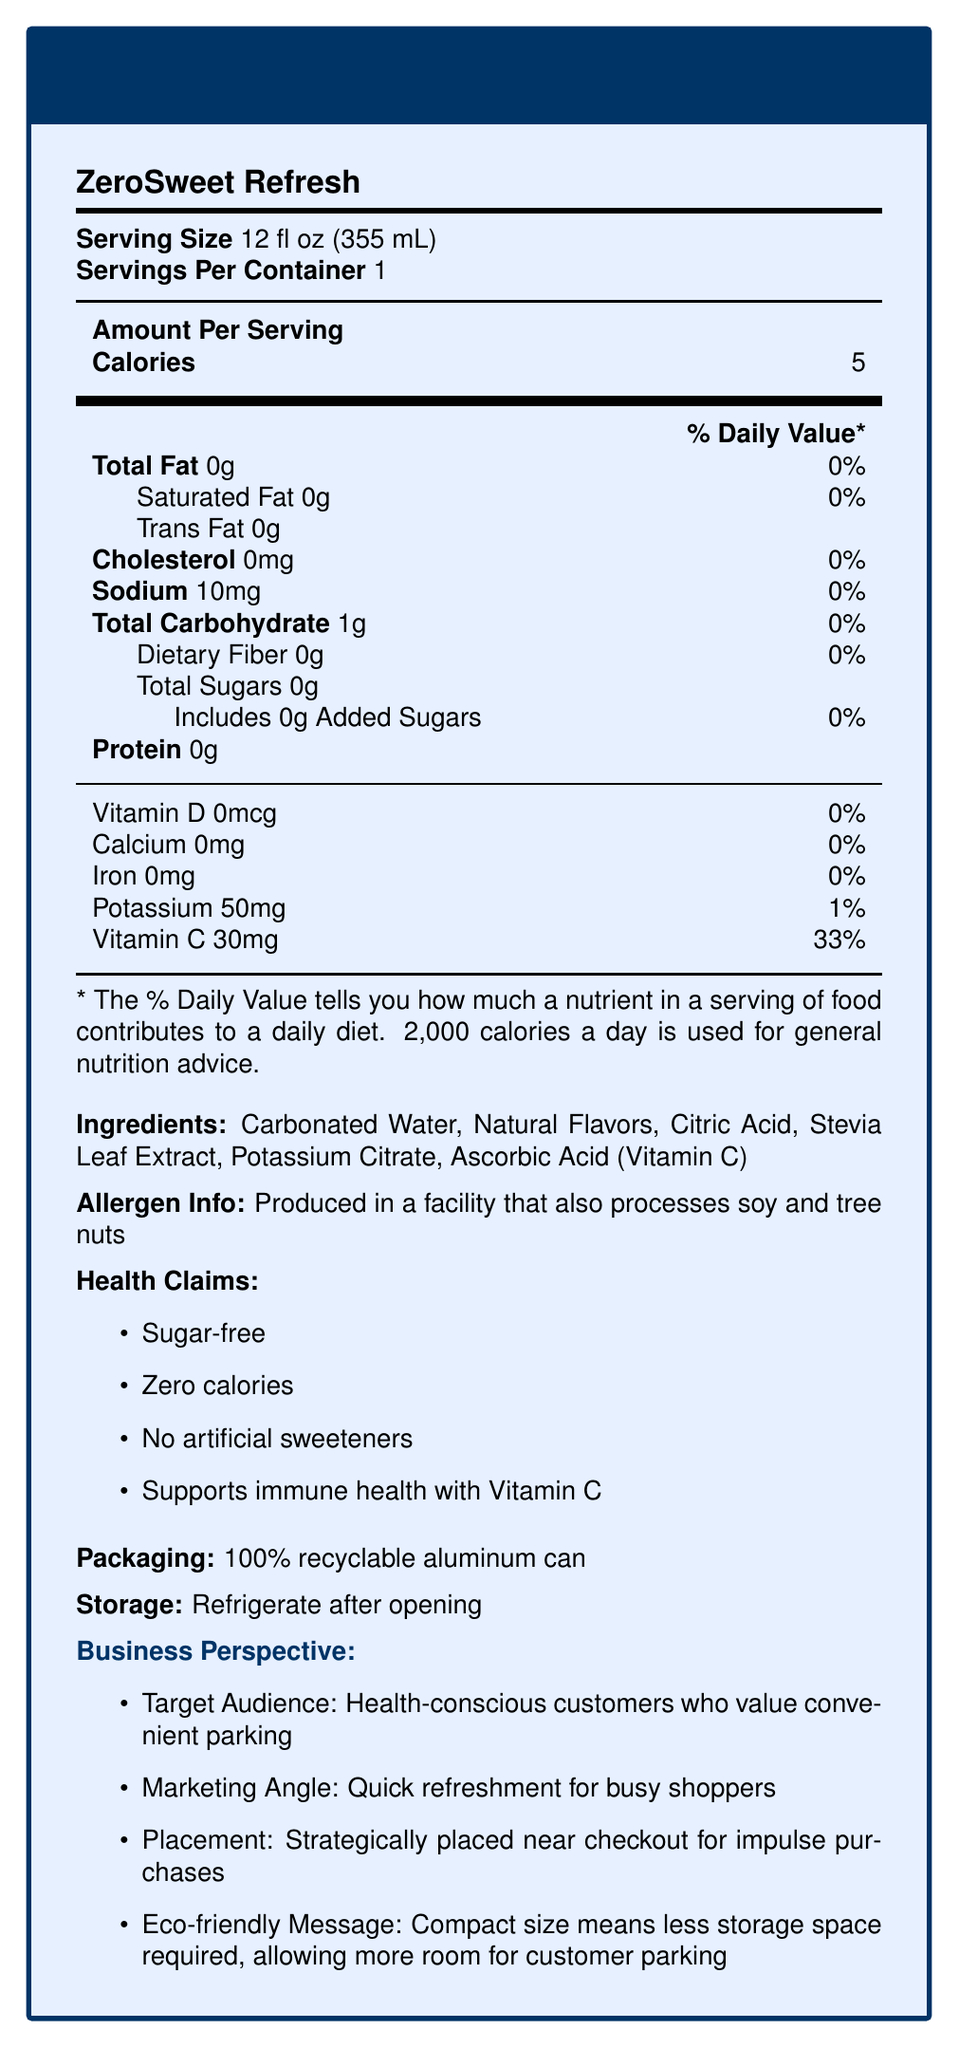what is the serving size of ZeroSweet Refresh? The document states that the serving size of ZeroSweet Refresh is 12 fl oz (355 mL).
Answer: 12 fl oz (355 mL) what is the calorie count per serving? According to the document, the amount per serving in terms of calories is 5.
Answer: 5 calories Is this beverage produced in a facility that processes allergens? The allergen information specifies that the beverage is produced in a facility that processes soy and tree nuts.
Answer: Yes what is the main sweetener used in ZeroSweet Refresh? The ingredients list includes "Stevia Leaf Extract," indicating it is the main sweetener.
Answer: Stevia Leaf Extract how much Vitamin C is in each serving? The document lists that each serving of ZeroSweet Refresh contains 30 mg of Vitamin C, which is 33% of the daily value.
Answer: 30 mg which of the following is NOT an ingredient in ZeroSweet Refresh? A. Citric Acid B. High Fructose Corn Syrup C. Potassium Citrate The ingredients list in the document does not include "High Fructose Corn Syrup."
Answer: B what is the percentage of daily value for potassium? The document specifies that each serving provides 50 mg of potassium, which is 1% of the daily value.
Answer: 1% Does ZeroSweet Refresh contain any added sugars? The document indicates that the total sugars are 0g, including 0g of added sugars.
Answer: No what is the claim related to immune health? One of the health claims listed in the document states that the beverage "Supports immune health with Vitamin C."
Answer: Supports immune health with Vitamin C Is the packaging recyclable? The document states that the packaging is a 100% recyclable aluminum can.
Answer: Yes how many servings are in one container of ZeroSweet Refresh? The document specifies that there is one serving per container.
Answer: 1 what is the total fat content in one serving? The total fat content listed in the document is 0g per serving.
Answer: 0g Based on the provided document, for whom is ZeroSweet Refresh primarily targeted? The business perspective section explicitly mentions the target audience as "health-conscious customers who value convenient parking."
Answer: Health-conscious customers who value convenient parking what is the total carbohydrate content per serving? A. 1g B. 2g C. 5g D. 0g The document states that the total carbohydrate content per serving is 1g.
Answer: A what is the purpose of placing ZeroSweet Refresh near the checkout? The business perspective section mentions that the placement strategy is to place ZeroSweet Refresh near the checkout for impulse purchases.
Answer: For impulse purchases Does ZeroSweet Refresh contain any dietary fiber? The dietary fiber content specified in the document is 0g per serving.
Answer: No summarize the main details of the document. This document contains detailed information about the nutritional content, ingredients, allergen info, health benefits, packaging, and storage of ZeroSweet Refresh. It also outlines the target audience and placement strategy from a business perspective.
Answer: ZeroSweet Refresh is a sugar-free beverage aimed at health-conscious customers, with a serving size of 12 fl oz and 5 calories per serving. It contains no fat, cholesterol, sugars, or protein, and provides 30mg of Vitamin C. Produced in a facility that processes soy and tree nuts, its ingredients include carbonated water, natural flavors, citric acid, stevia leaf extract, potassium citrate, and ascorbic acid. Packaged in a 100% recyclable aluminum can, it's recommended to refrigerate after opening. The target audience is health-conscious customers who value convenient parking, with strategic placement near checkouts for impulse purchases. what is the price of a ZeroSweet Refresh can? The document does not provide any pricing information for ZeroSweet Refresh.
Answer: Not enough information 